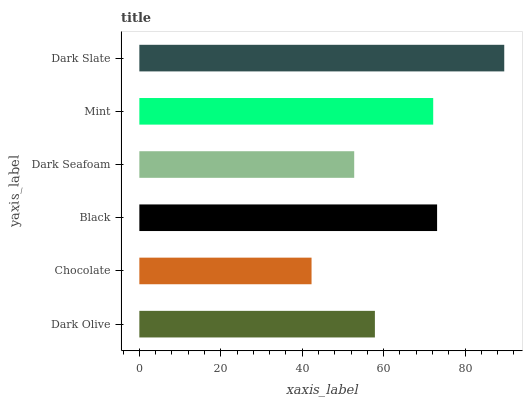Is Chocolate the minimum?
Answer yes or no. Yes. Is Dark Slate the maximum?
Answer yes or no. Yes. Is Black the minimum?
Answer yes or no. No. Is Black the maximum?
Answer yes or no. No. Is Black greater than Chocolate?
Answer yes or no. Yes. Is Chocolate less than Black?
Answer yes or no. Yes. Is Chocolate greater than Black?
Answer yes or no. No. Is Black less than Chocolate?
Answer yes or no. No. Is Mint the high median?
Answer yes or no. Yes. Is Dark Olive the low median?
Answer yes or no. Yes. Is Dark Olive the high median?
Answer yes or no. No. Is Chocolate the low median?
Answer yes or no. No. 